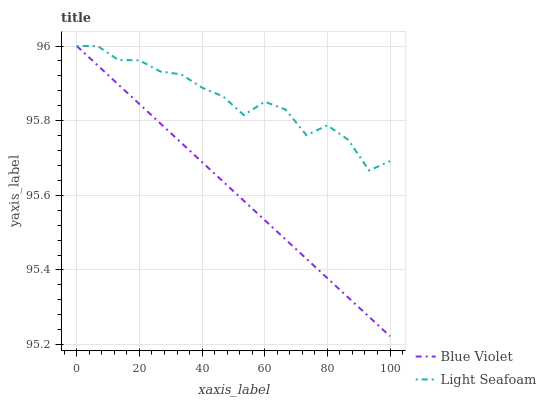Does Blue Violet have the minimum area under the curve?
Answer yes or no. Yes. Does Light Seafoam have the maximum area under the curve?
Answer yes or no. Yes. Does Blue Violet have the maximum area under the curve?
Answer yes or no. No. Is Blue Violet the smoothest?
Answer yes or no. Yes. Is Light Seafoam the roughest?
Answer yes or no. Yes. Is Blue Violet the roughest?
Answer yes or no. No. Does Blue Violet have the lowest value?
Answer yes or no. Yes. Does Blue Violet have the highest value?
Answer yes or no. Yes. Does Blue Violet intersect Light Seafoam?
Answer yes or no. Yes. Is Blue Violet less than Light Seafoam?
Answer yes or no. No. Is Blue Violet greater than Light Seafoam?
Answer yes or no. No. 